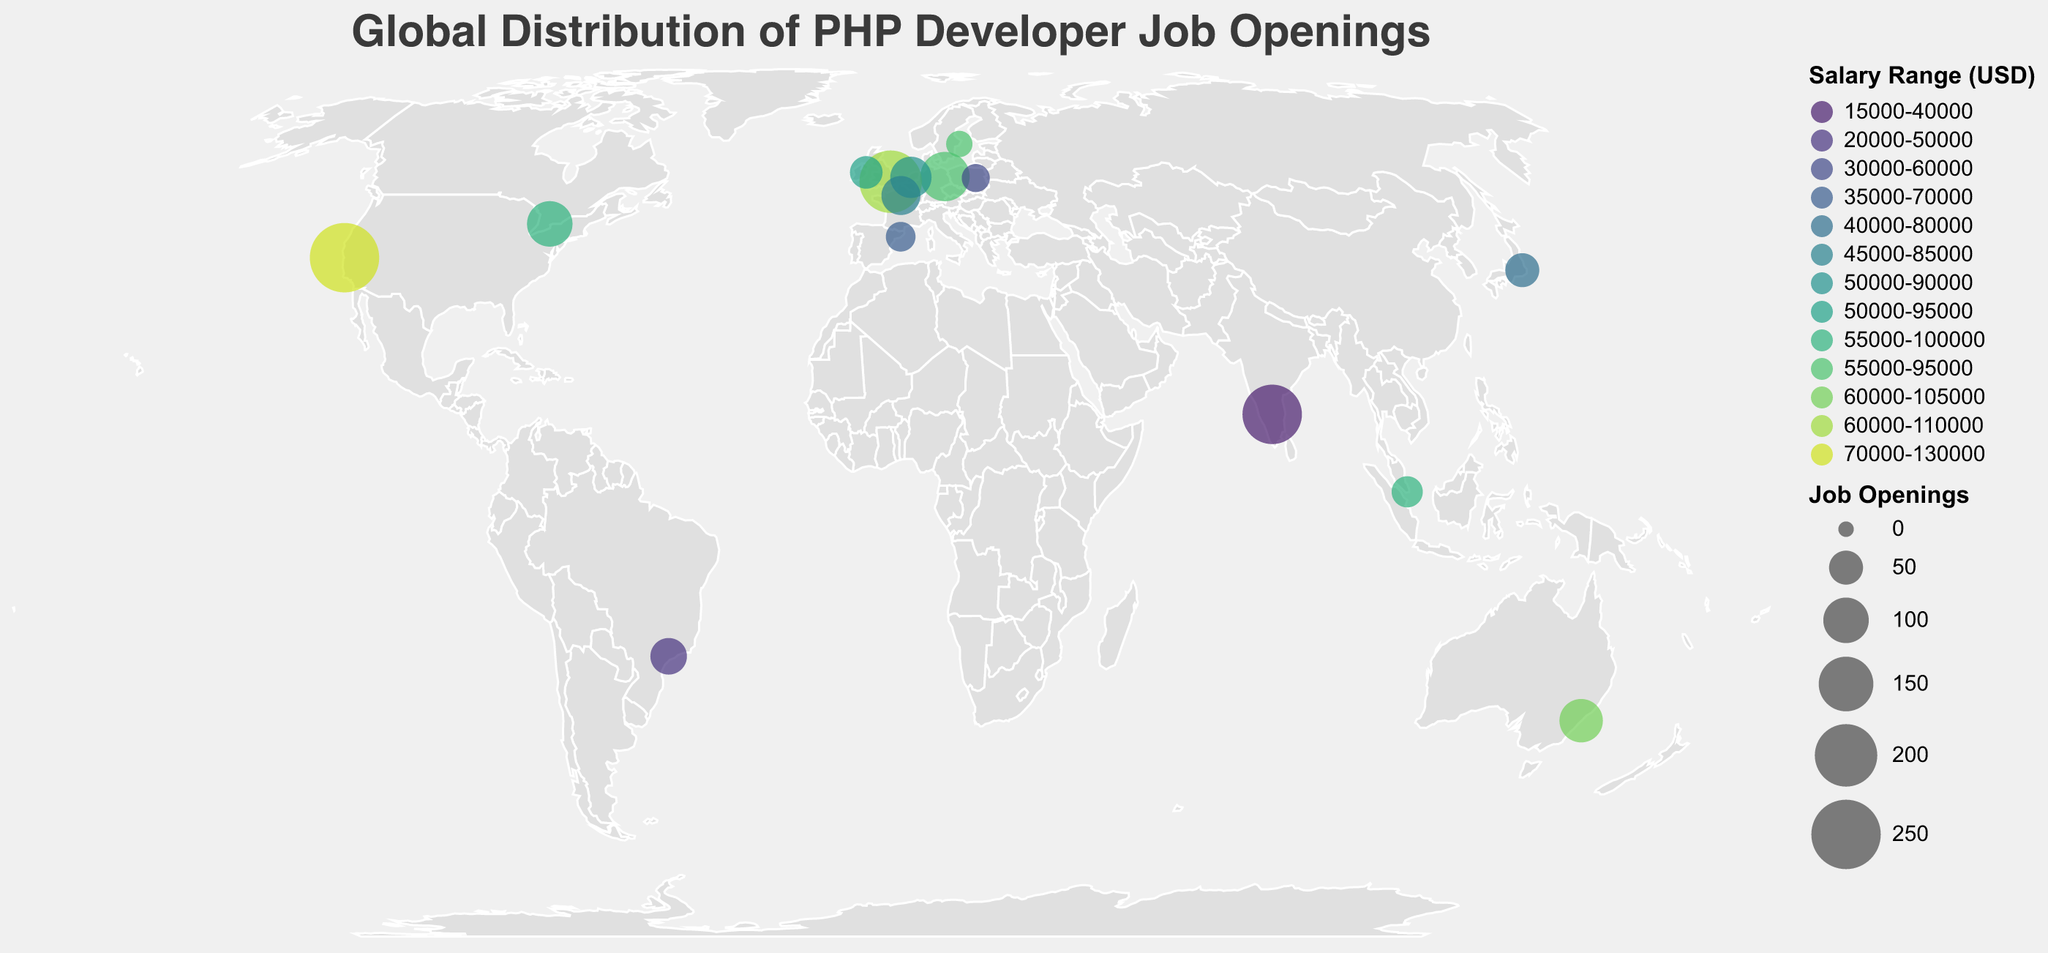What is the city with the most PHP developer job openings? The figure shows the size of circles representing job openings. The largest circle appears over San Francisco.
Answer: San Francisco What is the salary range for PHP developers in Berlin? The figure uses different colors to indicate salary ranges. The circle representing Berlin is colored within the range $55,000-$95,000.
Answer: $55,000-$95,000 How many cities have job openings with a maximum salary of at least $100,000? By counting the circles colored with a salary range that includes $100,000 or more, we identify San Francisco, London, Toronto, Sydney, and Singapore.
Answer: 5 Which city has the lowest salary range for PHP developers? The color representing the lowest salary range is for Bangalore, which has the range $15,000-$40,000.
Answer: Bangalore Compare the number of job openings between Tokyo and Sao Paulo. Which city has more job openings? The size of the circles is proportional to the number of job openings. Tokyo's circle is smaller than Sao Paulo's, indicating fewer openings in Tokyo.
Answer: Sao Paulo What is the average minimum salary for PHP developer job openings in European cities present in the plot? European cities in the plot include Berlin, London, Amsterdam, Paris, Warsaw, Barcelona, Dublin, and Stockholm. The minimum salaries are $55,000, $60,000, $50,000, $45,000, $30,000, $35,000, $50,000, $55,000. The average is (55000 + 60000 + 50000 + 45000 + 30000 + 35000 + 50000 + 55000)/8 = $47500.
Answer: $47,500 Which country in the southern hemisphere has PHP developer job openings listed, and what are the salary ranges there? The plot indicates cities in Australia and Brazil. Sydney (Australia) and Sao Paulo (Brazil) are in the southern hemisphere. The ranges are $60,000-$105,000 (Sydney) and $20,000-$50,000 (Sao Paulo).
Answer: Sydney: $60,000-$105,000, Sao Paulo: $20,000-$50,000 Which city has PHP job openings with the highest minimum salary, and what is that salary? San Francisco has the job openings with the highest minimum salary, which is $70,000.
Answer: San Francisco: $70,000 What is the total number of job openings in European cities? Summing the job openings in Berlin (120), London (200), Amsterdam (80), Paris (70), Warsaw (30), Barcelona (35), Dublin (45), and Stockholm (25) gives 120 + 200 + 80 + 70 + 30 + 35 + 45 + 25 = 605.
Answer: 605 